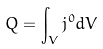Convert formula to latex. <formula><loc_0><loc_0><loc_500><loc_500>Q = \int _ { V } j ^ { 0 } d V</formula> 